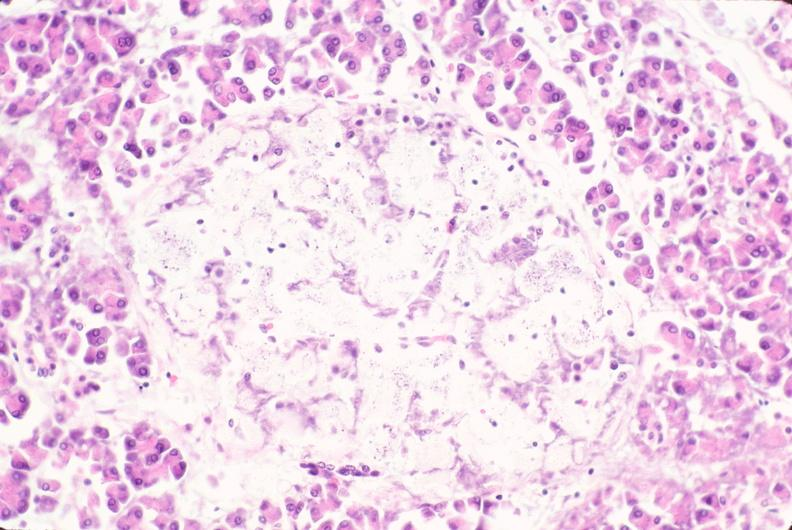does history show pancreas, islet hyalinization, diabetes mellitus?
Answer the question using a single word or phrase. No 